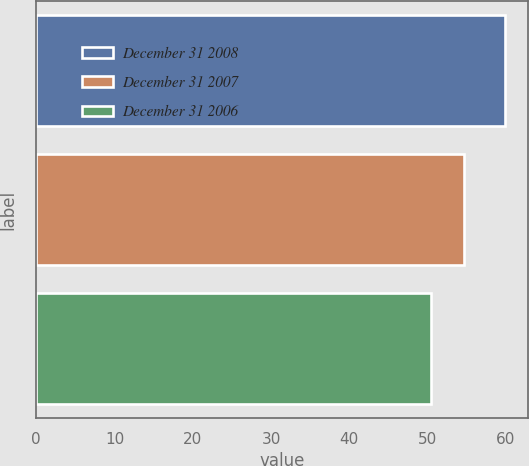Convert chart. <chart><loc_0><loc_0><loc_500><loc_500><bar_chart><fcel>December 31 2008<fcel>December 31 2007<fcel>December 31 2006<nl><fcel>59.9<fcel>54.7<fcel>50.5<nl></chart> 